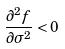Convert formula to latex. <formula><loc_0><loc_0><loc_500><loc_500>\frac { \partial ^ { 2 } f } { \partial \sigma ^ { 2 } } < 0</formula> 